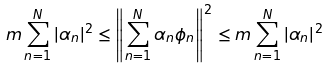<formula> <loc_0><loc_0><loc_500><loc_500>m \sum _ { n = 1 } ^ { N } | \alpha _ { n } | ^ { 2 } \leq \left \| \sum _ { n = 1 } ^ { N } \alpha _ { n } \phi _ { n } \right \| ^ { 2 } \leq m \sum _ { n = 1 } ^ { N } | \alpha _ { n } | ^ { 2 }</formula> 